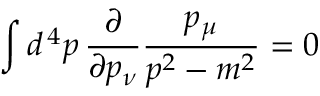Convert formula to latex. <formula><loc_0><loc_0><loc_500><loc_500>\int d ^ { \, 4 } p \, { \frac { \partial } { \partial p _ { \nu } } } { \frac { p _ { \mu } } { p ^ { 2 } - m ^ { 2 } } } = 0</formula> 